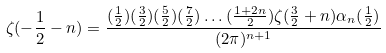Convert formula to latex. <formula><loc_0><loc_0><loc_500><loc_500>\zeta ( - \frac { 1 } { 2 } - n ) = \frac { ( \frac { 1 } { 2 } ) ( \frac { 3 } { 2 } ) ( \frac { 5 } { 2 } ) ( \frac { 7 } { 2 } ) \dots ( \frac { 1 + 2 n } { 2 } ) \zeta ( \frac { 3 } { 2 } + n ) \alpha { _ { n } ( \frac { 1 } { 2 } ) } } { ( 2 \pi ) ^ { n + 1 } }</formula> 